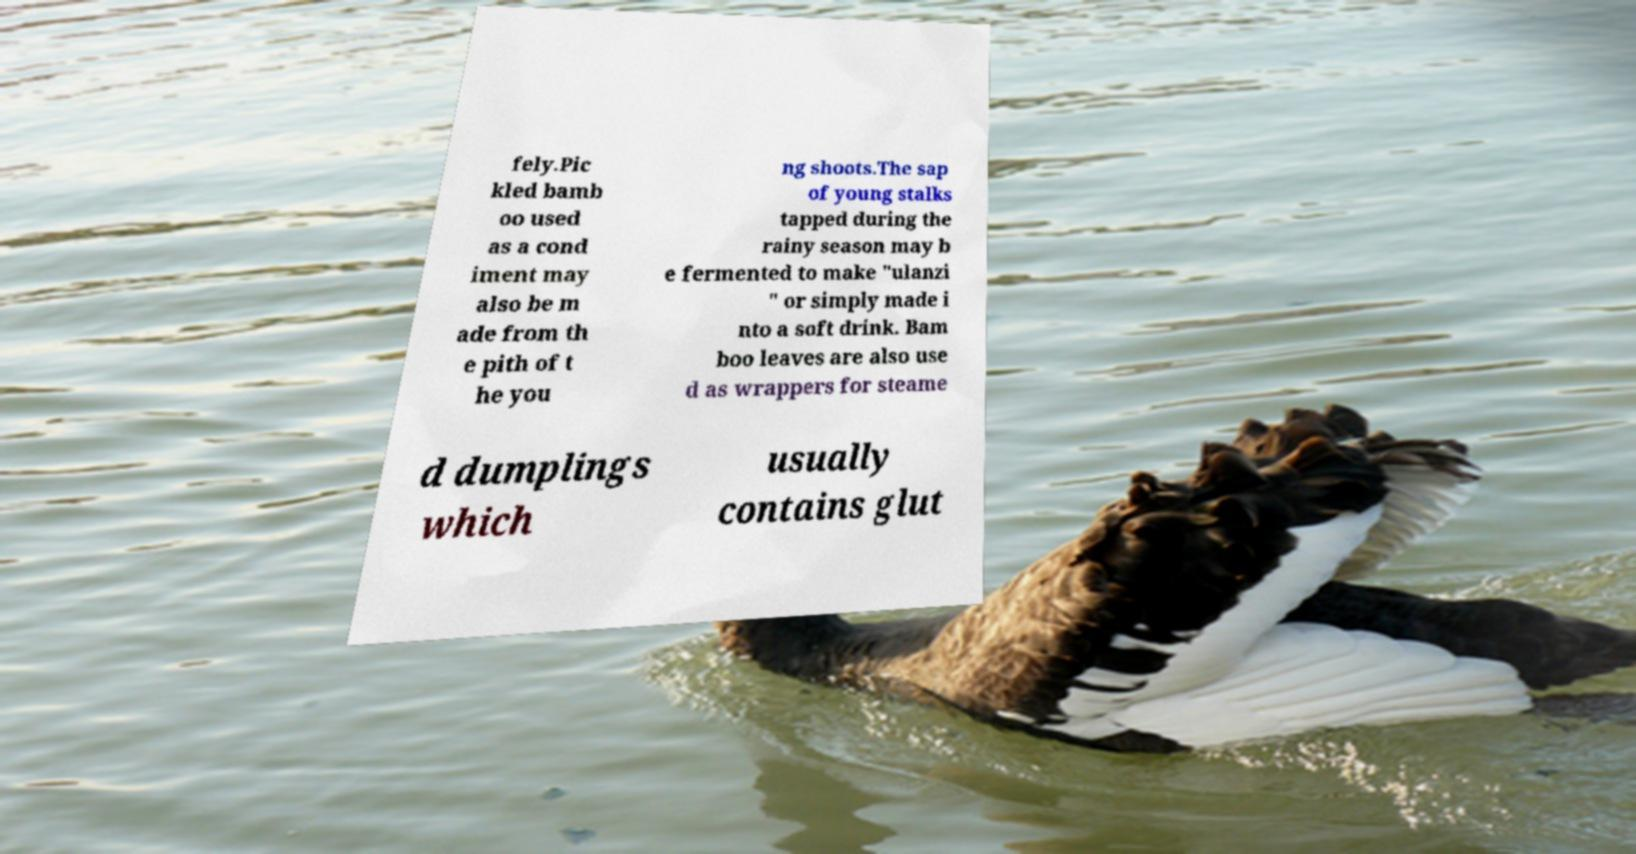Could you assist in decoding the text presented in this image and type it out clearly? fely.Pic kled bamb oo used as a cond iment may also be m ade from th e pith of t he you ng shoots.The sap of young stalks tapped during the rainy season may b e fermented to make "ulanzi " or simply made i nto a soft drink. Bam boo leaves are also use d as wrappers for steame d dumplings which usually contains glut 